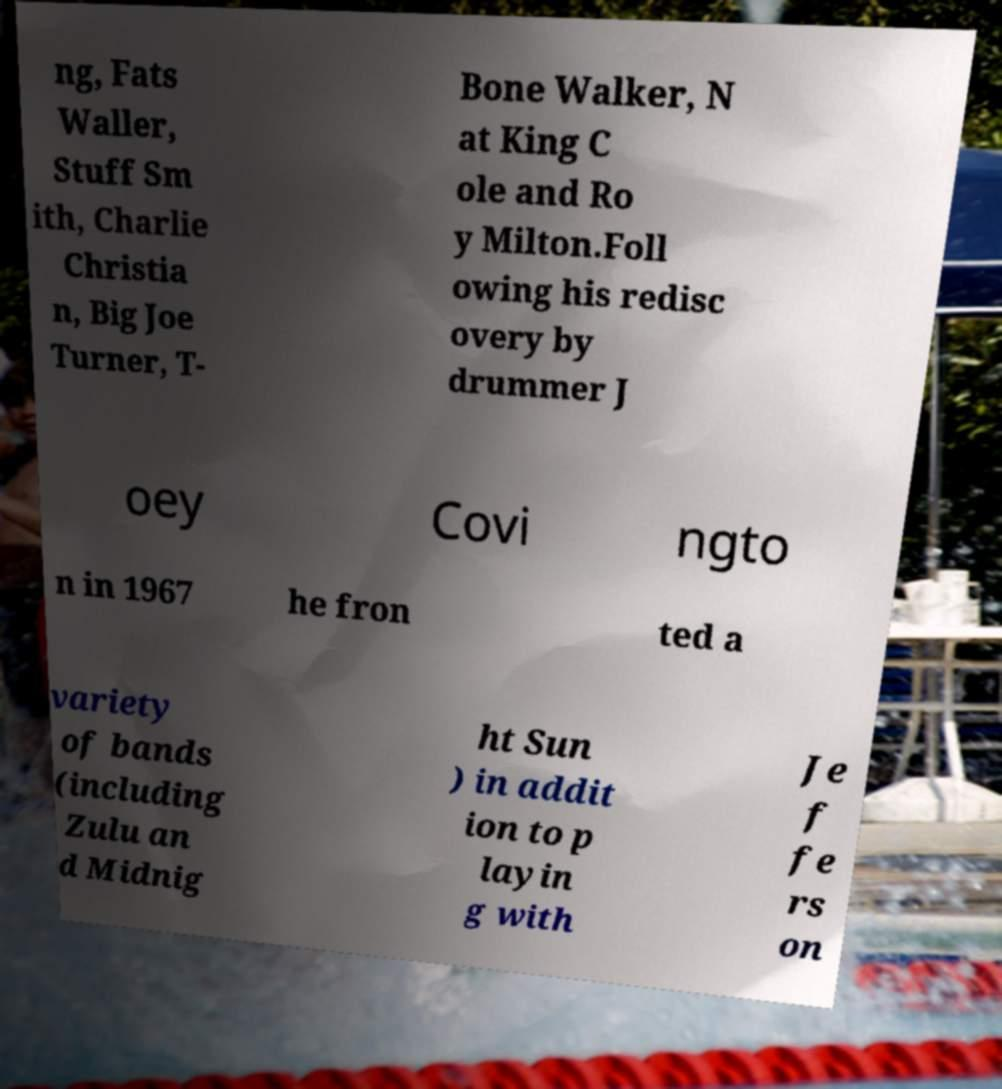Please identify and transcribe the text found in this image. ng, Fats Waller, Stuff Sm ith, Charlie Christia n, Big Joe Turner, T- Bone Walker, N at King C ole and Ro y Milton.Foll owing his redisc overy by drummer J oey Covi ngto n in 1967 he fron ted a variety of bands (including Zulu an d Midnig ht Sun ) in addit ion to p layin g with Je f fe rs on 